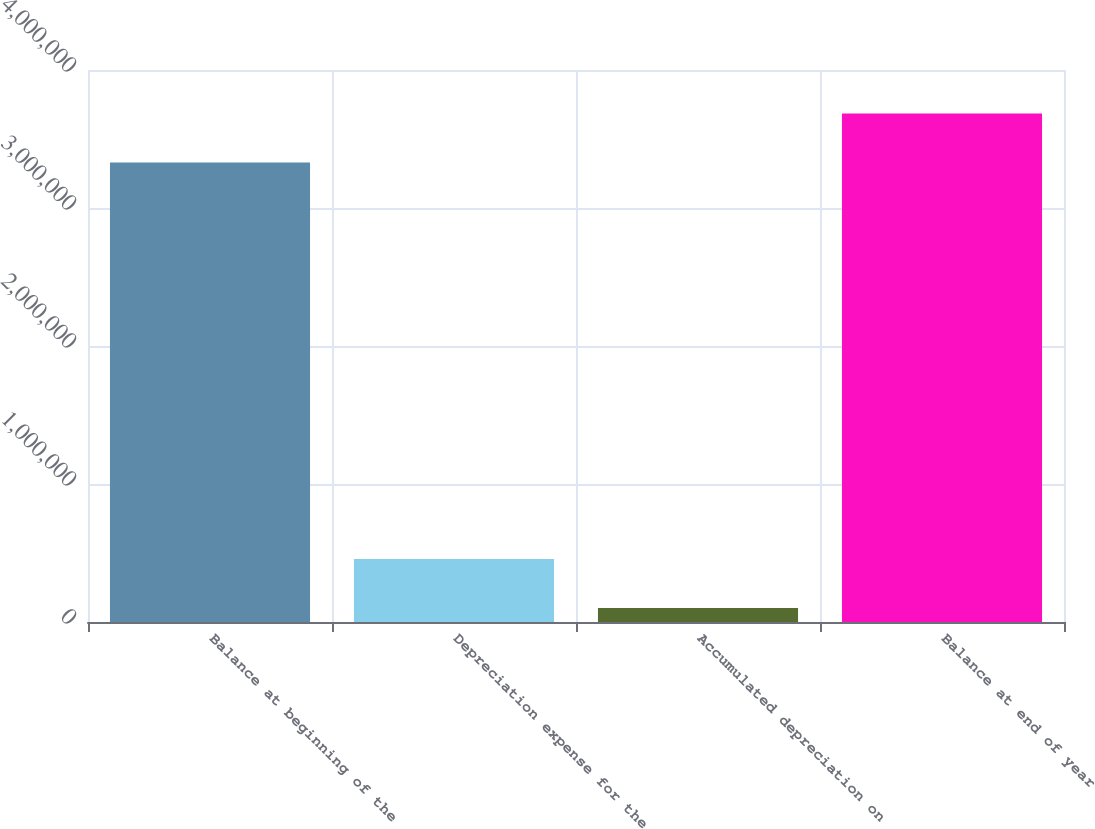Convert chart to OTSL. <chart><loc_0><loc_0><loc_500><loc_500><bar_chart><fcel>Balance at beginning of the<fcel>Depreciation expense for the<fcel>Accumulated depreciation on<fcel>Balance at end of year<nl><fcel>3.33017e+06<fcel>457227<fcel>102012<fcel>3.68538e+06<nl></chart> 